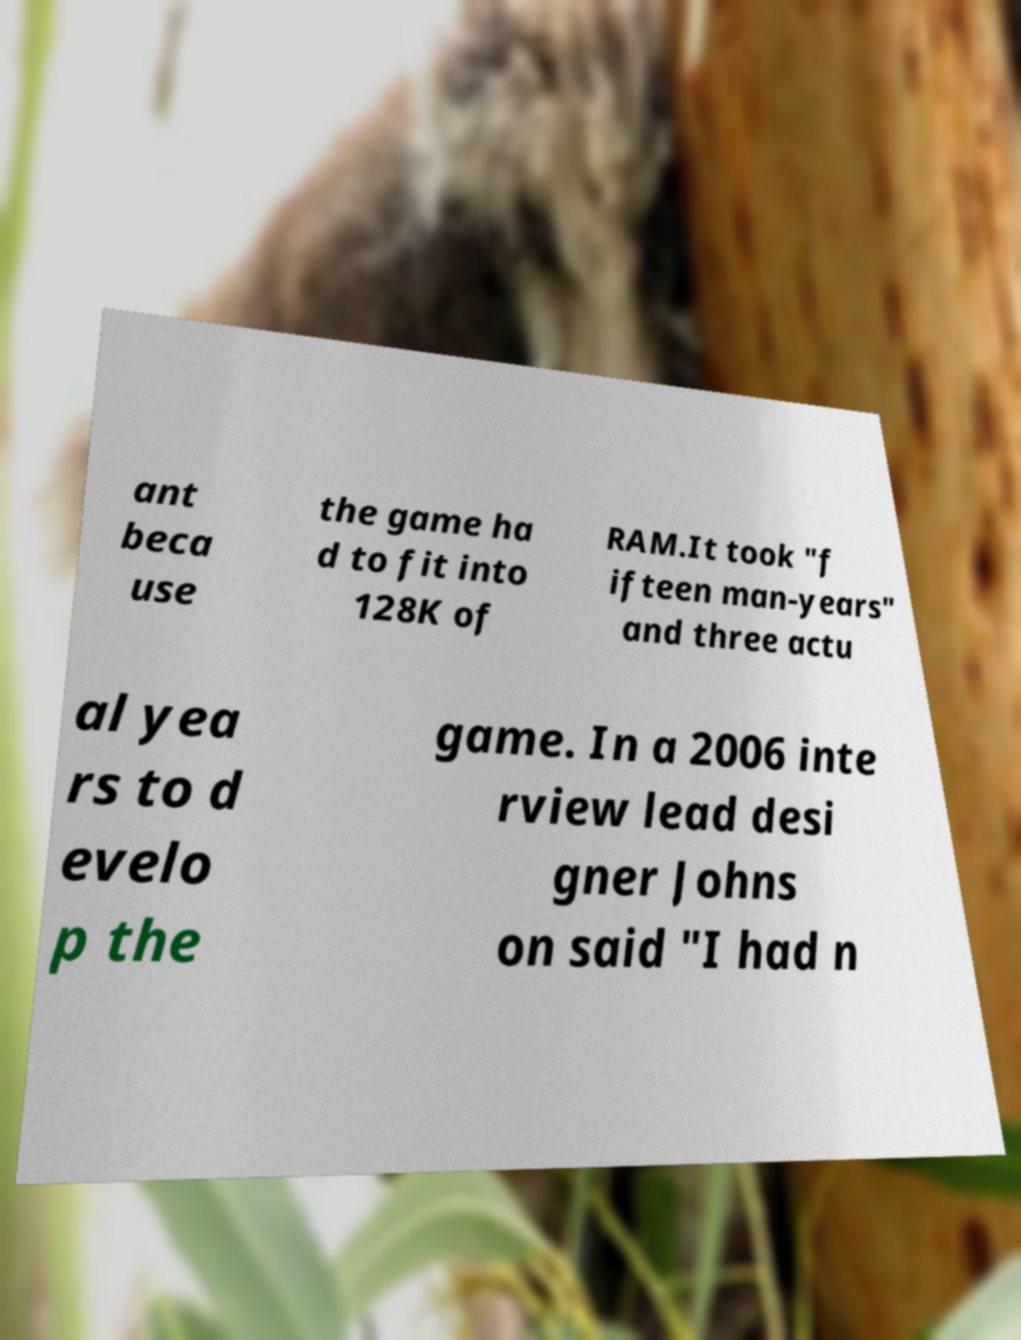I need the written content from this picture converted into text. Can you do that? ant beca use the game ha d to fit into 128K of RAM.It took "f ifteen man-years" and three actu al yea rs to d evelo p the game. In a 2006 inte rview lead desi gner Johns on said "I had n 